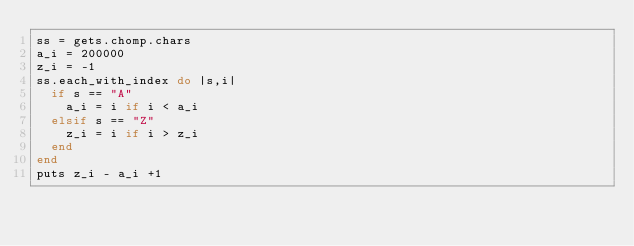<code> <loc_0><loc_0><loc_500><loc_500><_Ruby_>ss = gets.chomp.chars
a_i = 200000
z_i = -1
ss.each_with_index do |s,i|
  if s == "A"
    a_i = i if i < a_i
  elsif s == "Z"
    z_i = i if i > z_i
  end
end
puts z_i - a_i +1</code> 